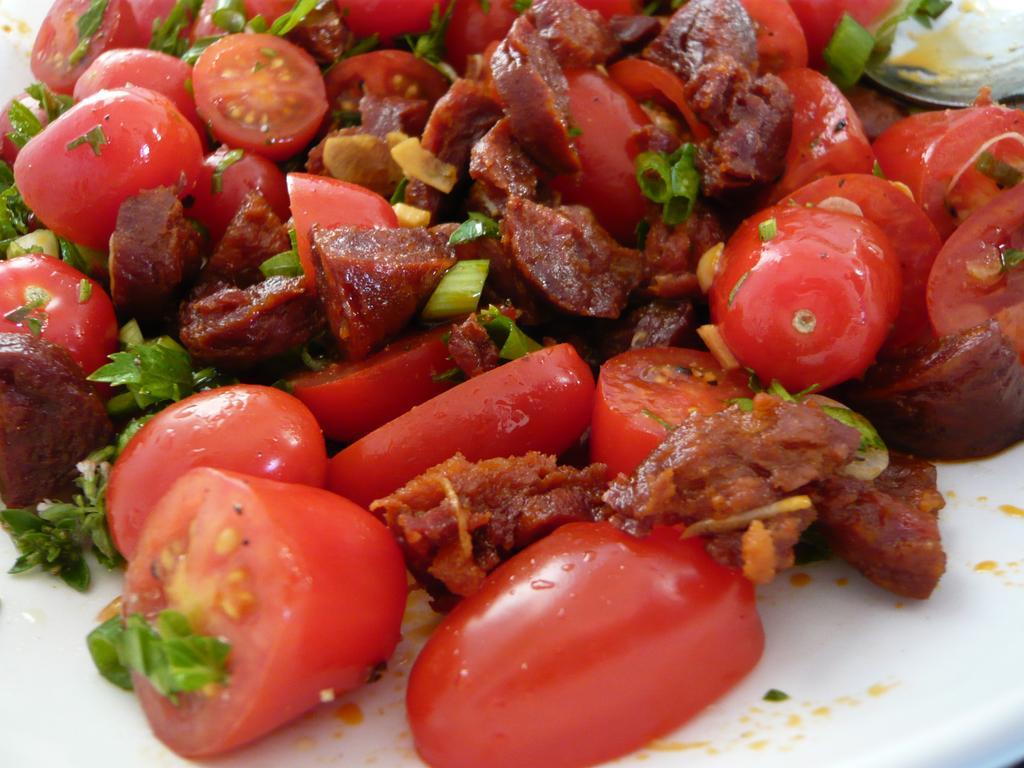Could you give a brief overview of what you see in this image? In this image I can see food items on a white color surface. 